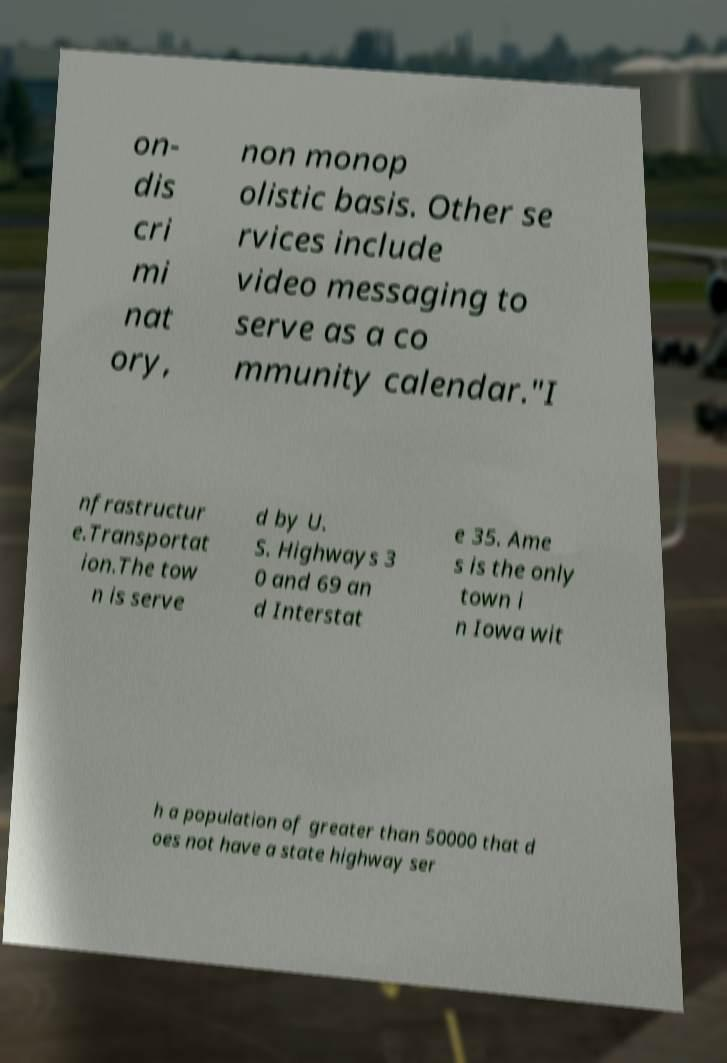For documentation purposes, I need the text within this image transcribed. Could you provide that? on- dis cri mi nat ory, non monop olistic basis. Other se rvices include video messaging to serve as a co mmunity calendar."I nfrastructur e.Transportat ion.The tow n is serve d by U. S. Highways 3 0 and 69 an d Interstat e 35. Ame s is the only town i n Iowa wit h a population of greater than 50000 that d oes not have a state highway ser 